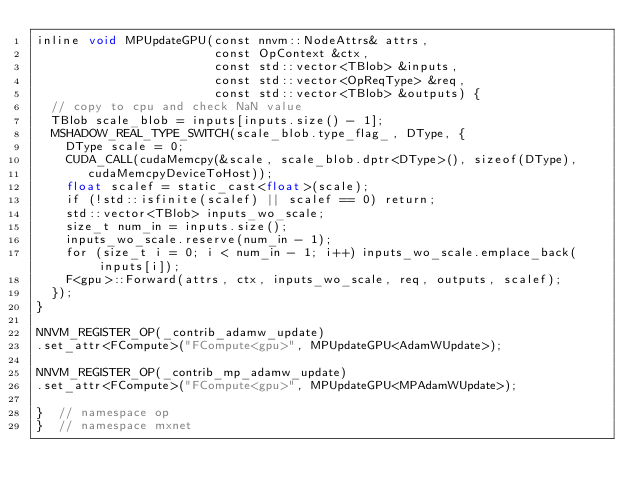Convert code to text. <code><loc_0><loc_0><loc_500><loc_500><_Cuda_>inline void MPUpdateGPU(const nnvm::NodeAttrs& attrs,
                        const OpContext &ctx,
                        const std::vector<TBlob> &inputs,
                        const std::vector<OpReqType> &req,
                        const std::vector<TBlob> &outputs) {
  // copy to cpu and check NaN value
  TBlob scale_blob = inputs[inputs.size() - 1];
  MSHADOW_REAL_TYPE_SWITCH(scale_blob.type_flag_, DType, {
    DType scale = 0;
    CUDA_CALL(cudaMemcpy(&scale, scale_blob.dptr<DType>(), sizeof(DType),
       cudaMemcpyDeviceToHost));
    float scalef = static_cast<float>(scale);
    if (!std::isfinite(scalef) || scalef == 0) return;
    std::vector<TBlob> inputs_wo_scale;
    size_t num_in = inputs.size();
    inputs_wo_scale.reserve(num_in - 1);
    for (size_t i = 0; i < num_in - 1; i++) inputs_wo_scale.emplace_back(inputs[i]);
    F<gpu>::Forward(attrs, ctx, inputs_wo_scale, req, outputs, scalef);
  });
}

NNVM_REGISTER_OP(_contrib_adamw_update)
.set_attr<FCompute>("FCompute<gpu>", MPUpdateGPU<AdamWUpdate>);

NNVM_REGISTER_OP(_contrib_mp_adamw_update)
.set_attr<FCompute>("FCompute<gpu>", MPUpdateGPU<MPAdamWUpdate>);

}  // namespace op
}  // namespace mxnet
</code> 